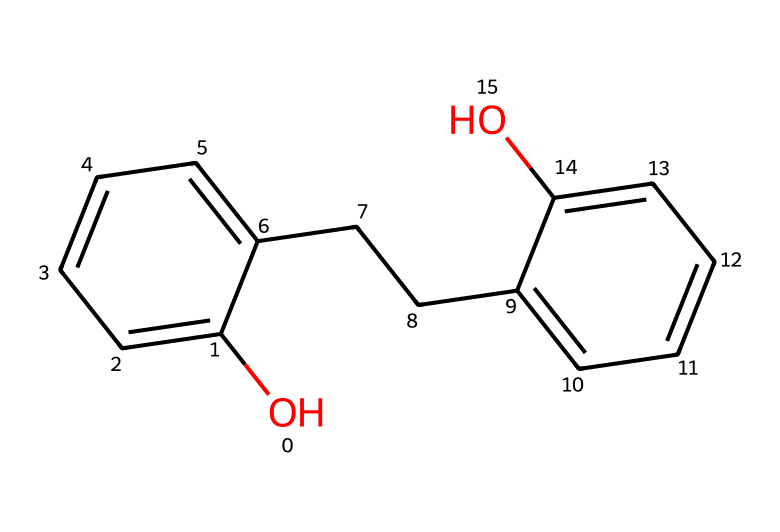What is the total number of carbon atoms in this compound? Analyzing the SMILES representation, we identify each carbon atom represented by 'c' (for aromatic carbon) and 'C' (for aliphatic carbon). Counting all 'c' and 'C' in the structure gives a total of 16 carbon atoms.
Answer: 16 How many hydroxyl (-OH) groups are present in this chemical? In the provided SMILES notation, the 'O' followed by a lowercase 'c' indicates a hydroxyl (-OH) group attached to one of the aromatic rings. There are two such 'O's present in the structure, indicating that there are two hydroxyl groups.
Answer: 2 What type of chemical bond connects the hydroxyl group to the aromatic ring? In the structure, the -OH group is directly attached to one of the aromatic carbon atoms via a single bond (indicated by the lack of any special notation in the SMILES). Thus, the connection between the hydroxyl group and the aromatic ring involves a single covalent bond.
Answer: single bond Does this compound contain any aliphatic chains? The presence of a chain of carbons (not in a ring) evident in the SMILES structure, where 'CC' indicates a two-carbon straight chain (aliphatic), confirms the existence of aliphatic components alongside the aromatic rings.
Answer: yes Which functional group primarily contributes to the adhesive properties of this resin? The hydroxyl groups (-OH) are known for their ability to form hydrogen bonds which enhance adhesion and compatibility with other materials, making them vital for the adhesive properties of phenol-formaldehyde resins.
Answer: hydroxyl What is the primary aromatic structure present in this compound? The structure contains two fused aromatic rings with hydroxyl groups, exemplifying its nature as a phenolic compound. The recurrence of 'c' in the SMILES indicates the presence of phenolic structures.
Answer: phenolic structure How does this compound behave in acidic conditions? Phenols tend to donate protons in acidic solutions due to the hydroxyl group, making them slightly acidic. Therefore, in acidic conditions, it would participate in acid-base reactions and could potentially contribute to changes in pH.
Answer: slightly acidic 